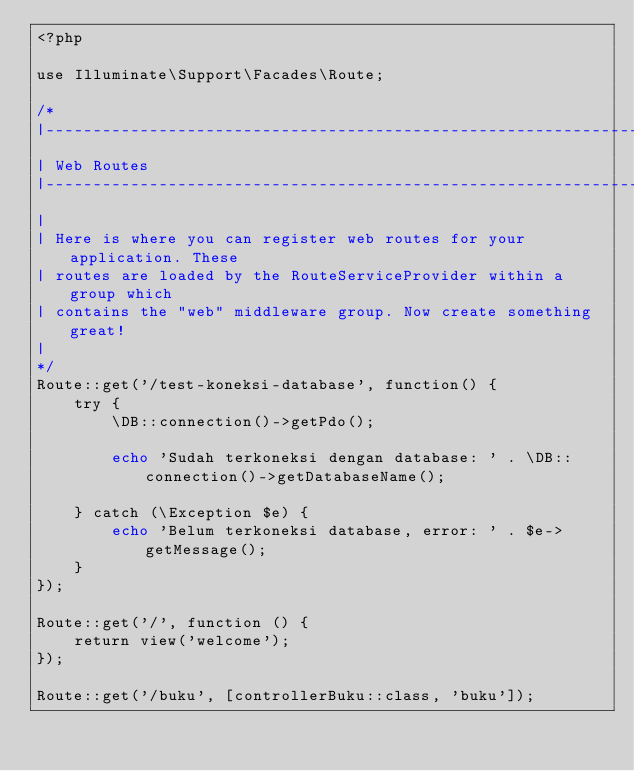<code> <loc_0><loc_0><loc_500><loc_500><_PHP_><?php

use Illuminate\Support\Facades\Route;

/*
|--------------------------------------------------------------------------
| Web Routes
|--------------------------------------------------------------------------
|
| Here is where you can register web routes for your application. These
| routes are loaded by the RouteServiceProvider within a group which
| contains the "web" middleware group. Now create something great!
|
*/
Route::get('/test-koneksi-database', function() {
	try {
		\DB::connection()->getPdo();

		echo 'Sudah terkoneksi dengan database: ' . \DB::connection()->getDatabaseName();

	} catch (\Exception $e) {
		echo 'Belum terkoneksi database, error: ' . $e->getMessage();
	}
});

Route::get('/', function () {
    return view('welcome');
});

Route::get('/buku', [controllerBuku::class, 'buku']); 
</code> 